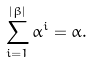Convert formula to latex. <formula><loc_0><loc_0><loc_500><loc_500>\sum _ { i = 1 } ^ { | \beta | } \alpha ^ { i } = \alpha .</formula> 